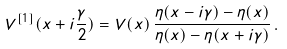<formula> <loc_0><loc_0><loc_500><loc_500>V ^ { [ 1 ] } ( x + i \frac { \gamma } { 2 } ) = V ( x ) \, \frac { \eta ( x - i \gamma ) - \eta ( x ) } { \eta ( x ) - \eta ( x + i \gamma ) } \, .</formula> 